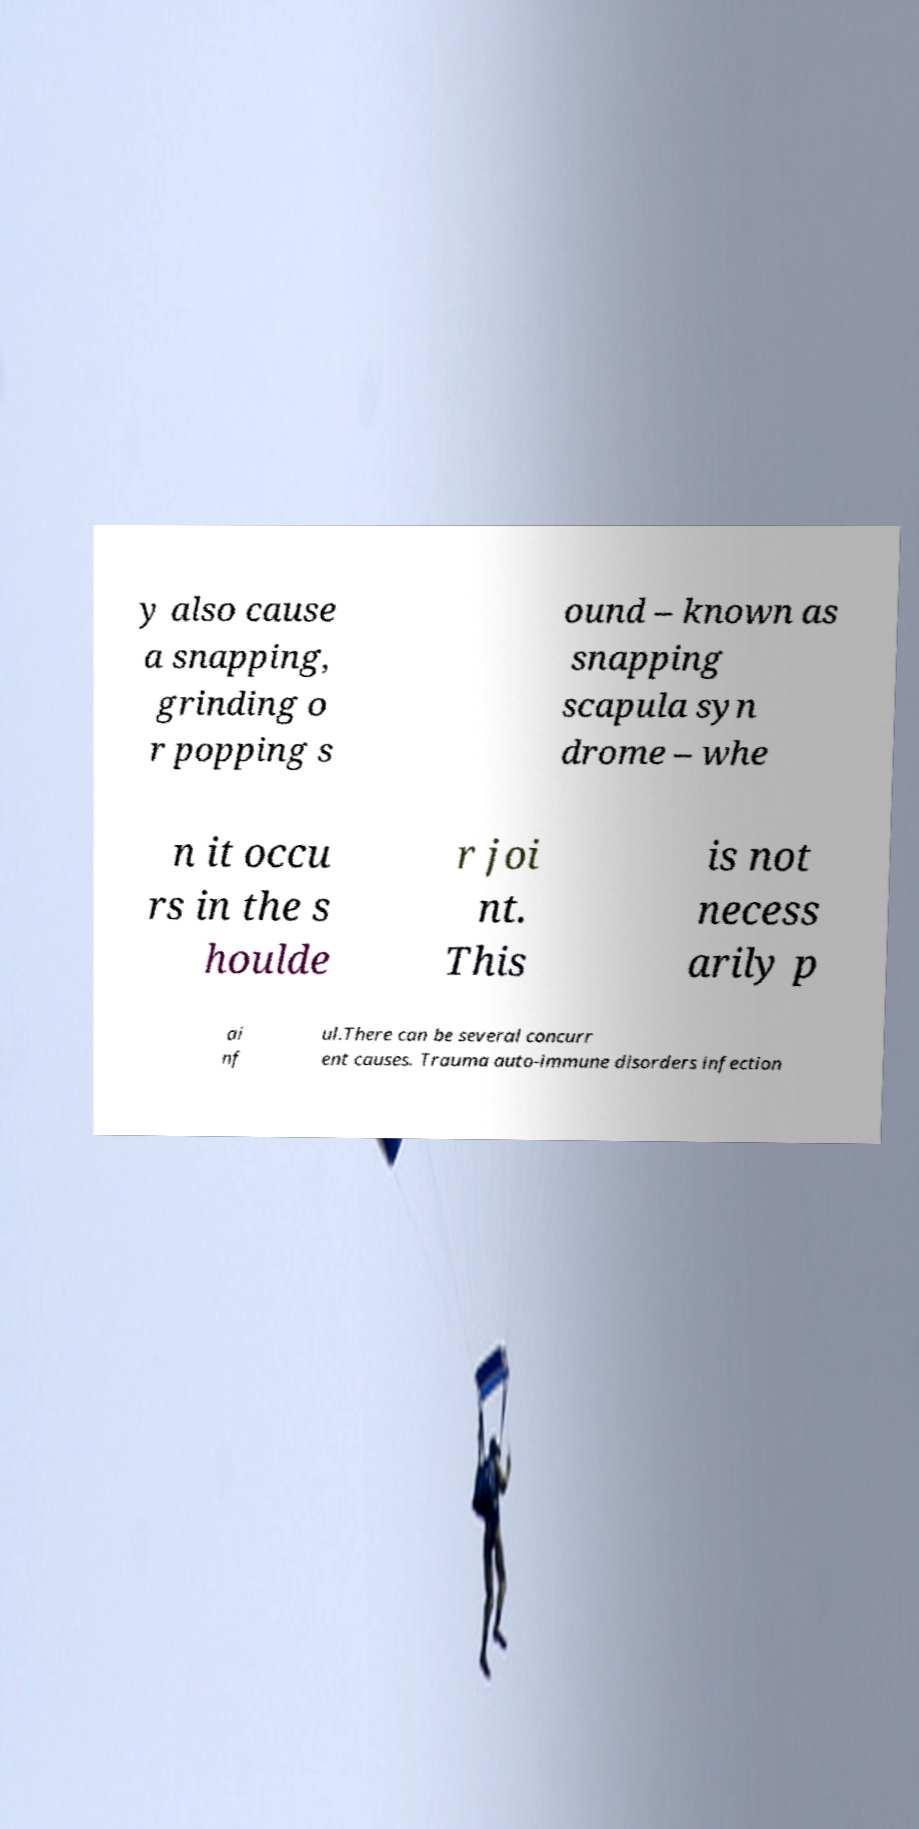I need the written content from this picture converted into text. Can you do that? y also cause a snapping, grinding o r popping s ound – known as snapping scapula syn drome – whe n it occu rs in the s houlde r joi nt. This is not necess arily p ai nf ul.There can be several concurr ent causes. Trauma auto-immune disorders infection 